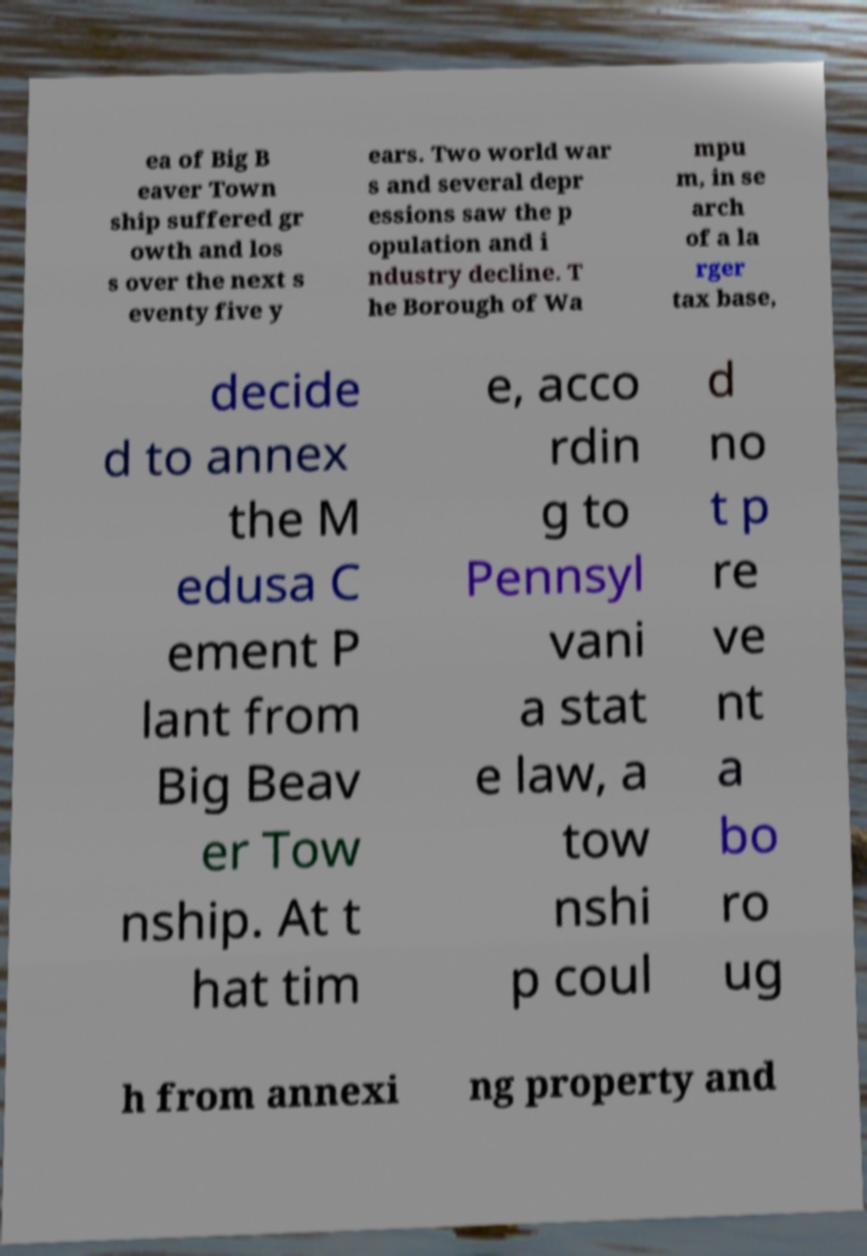Can you read and provide the text displayed in the image?This photo seems to have some interesting text. Can you extract and type it out for me? ea of Big B eaver Town ship suffered gr owth and los s over the next s eventy five y ears. Two world war s and several depr essions saw the p opulation and i ndustry decline. T he Borough of Wa mpu m, in se arch of a la rger tax base, decide d to annex the M edusa C ement P lant from Big Beav er Tow nship. At t hat tim e, acco rdin g to Pennsyl vani a stat e law, a tow nshi p coul d no t p re ve nt a bo ro ug h from annexi ng property and 